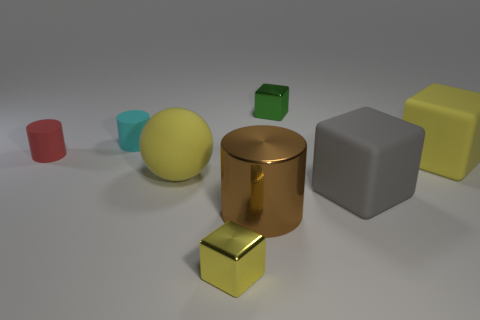Subtract all tiny rubber cylinders. How many cylinders are left? 1 Subtract all cyan cubes. Subtract all cyan spheres. How many cubes are left? 4 Add 1 tiny cyan matte cylinders. How many objects exist? 9 Subtract all cylinders. How many objects are left? 5 Add 6 yellow matte objects. How many yellow matte objects exist? 8 Subtract 0 red blocks. How many objects are left? 8 Subtract all small yellow objects. Subtract all gray rubber objects. How many objects are left? 6 Add 5 big gray rubber cubes. How many big gray rubber cubes are left? 6 